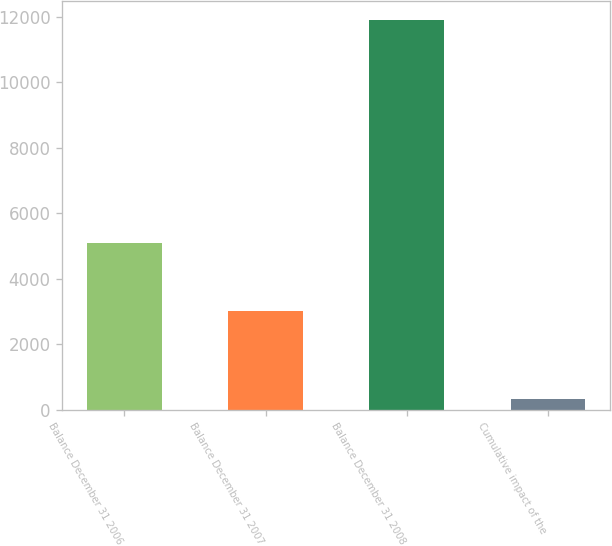<chart> <loc_0><loc_0><loc_500><loc_500><bar_chart><fcel>Balance December 31 2006<fcel>Balance December 31 2007<fcel>Balance December 31 2008<fcel>Cumulative impact of the<nl><fcel>5103<fcel>3025<fcel>11893<fcel>322<nl></chart> 